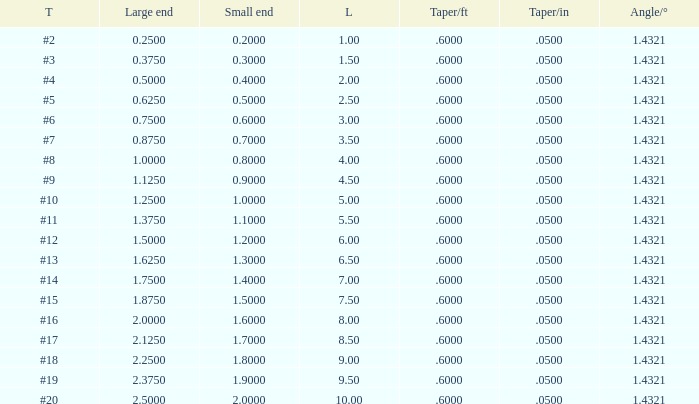Which Large end has a Taper/ft smaller than 0.6000000000000001? 19.0. Give me the full table as a dictionary. {'header': ['T', 'Large end', 'Small end', 'L', 'Taper/ft', 'Taper/in', 'Angle/°'], 'rows': [['#2', '0.2500', '0.2000', '1.00', '.6000', '.0500', '1.4321'], ['#3', '0.3750', '0.3000', '1.50', '.6000', '.0500', '1.4321'], ['#4', '0.5000', '0.4000', '2.00', '.6000', '.0500', '1.4321'], ['#5', '0.6250', '0.5000', '2.50', '.6000', '.0500', '1.4321'], ['#6', '0.7500', '0.6000', '3.00', '.6000', '.0500', '1.4321'], ['#7', '0.8750', '0.7000', '3.50', '.6000', '.0500', '1.4321'], ['#8', '1.0000', '0.8000', '4.00', '.6000', '.0500', '1.4321'], ['#9', '1.1250', '0.9000', '4.50', '.6000', '.0500', '1.4321'], ['#10', '1.2500', '1.0000', '5.00', '.6000', '.0500', '1.4321'], ['#11', '1.3750', '1.1000', '5.50', '.6000', '.0500', '1.4321'], ['#12', '1.5000', '1.2000', '6.00', '.6000', '.0500', '1.4321'], ['#13', '1.6250', '1.3000', '6.50', '.6000', '.0500', '1.4321'], ['#14', '1.7500', '1.4000', '7.00', '.6000', '.0500', '1.4321'], ['#15', '1.8750', '1.5000', '7.50', '.6000', '.0500', '1.4321'], ['#16', '2.0000', '1.6000', '8.00', '.6000', '.0500', '1.4321'], ['#17', '2.1250', '1.7000', '8.50', '.6000', '.0500', '1.4321'], ['#18', '2.2500', '1.8000', '9.00', '.6000', '.0500', '1.4321'], ['#19', '2.3750', '1.9000', '9.50', '.6000', '.0500', '1.4321'], ['#20', '2.5000', '2.0000', '10.00', '.6000', '.0500', '1.4321']]} 